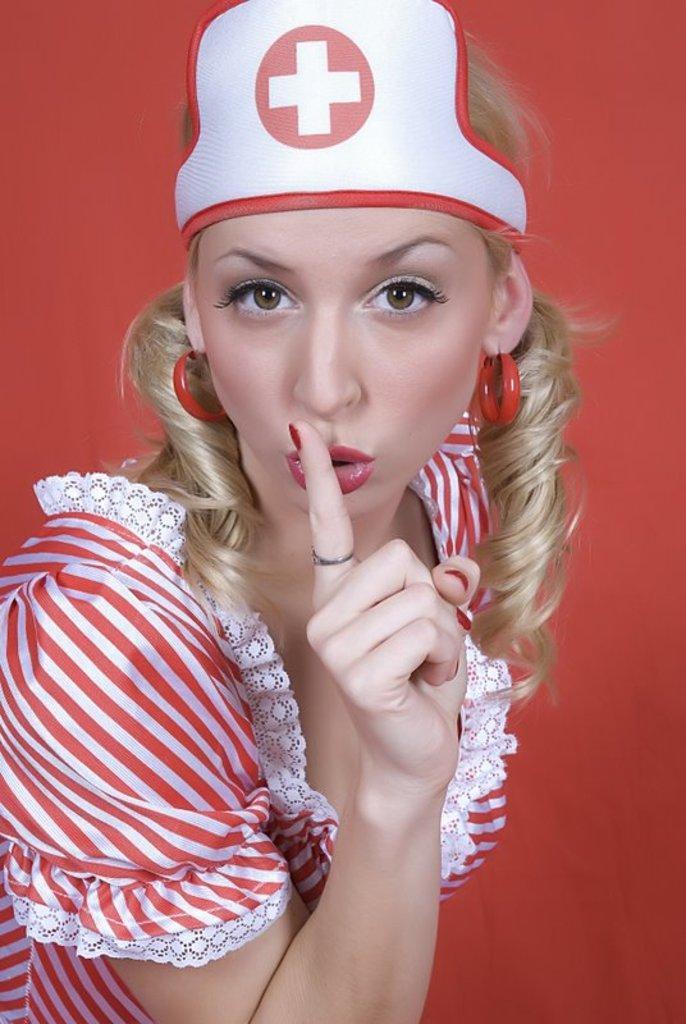In one or two sentences, can you explain what this image depicts? This image consists of a woman in red dress and a cap. In the background, there is a wall with red color. She is also wearing earrings in red color. 